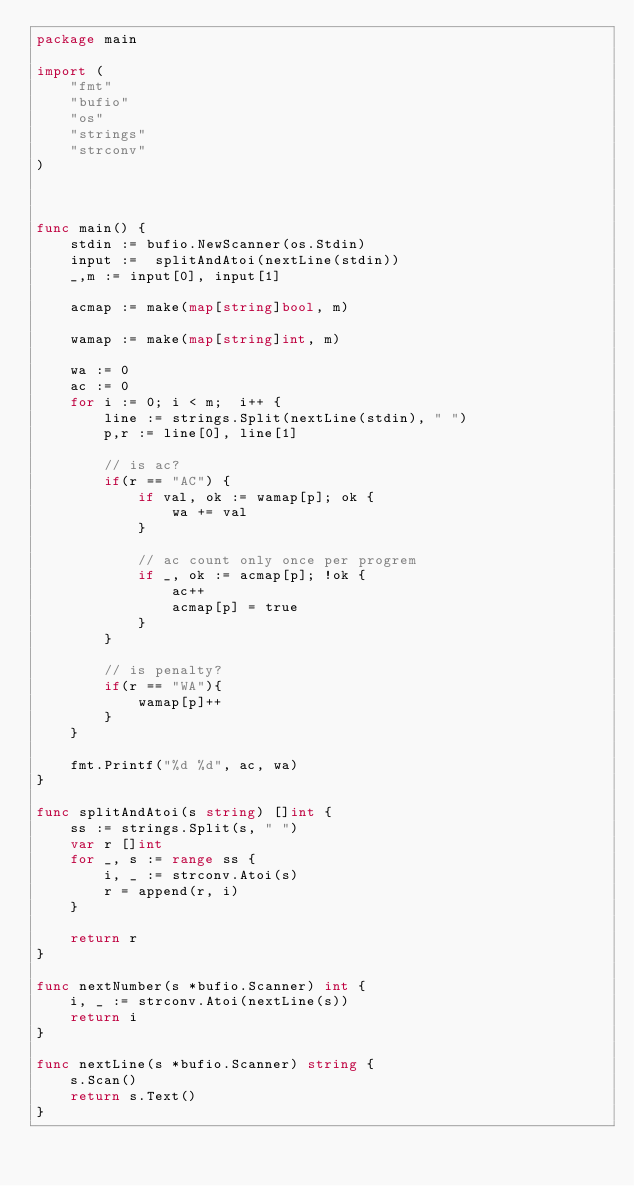Convert code to text. <code><loc_0><loc_0><loc_500><loc_500><_Go_>package main

import (
	"fmt"
	"bufio"
	"os"
	"strings"
	"strconv"
)



func main() {
	stdin := bufio.NewScanner(os.Stdin)
	input :=  splitAndAtoi(nextLine(stdin))
	_,m := input[0], input[1]

	acmap := make(map[string]bool, m)

	wamap := make(map[string]int, m)

	wa := 0
	ac := 0
	for i := 0; i < m;  i++ {
		line :=	strings.Split(nextLine(stdin), " ")
		p,r := line[0], line[1]

		// is ac?
		if(r == "AC") {
			if val, ok := wamap[p]; ok {
				wa += val			
			}
			
			// ac count only once per progrem
			if _, ok := acmap[p]; !ok {
				ac++
				acmap[p] = true
			}
		}

		// is penalty?
		if(r == "WA"){
			wamap[p]++
		}
	}

	fmt.Printf("%d %d", ac, wa)
}

func splitAndAtoi(s string) []int {
	ss := strings.Split(s, " ")
	var r []int
	for _, s := range ss {
		i, _ := strconv.Atoi(s)
		r = append(r, i)
	}

	return r
}

func nextNumber(s *bufio.Scanner) int {
	i, _ := strconv.Atoi(nextLine(s))
	return i
}

func nextLine(s *bufio.Scanner) string {
	s.Scan()
	return s.Text()
}
</code> 